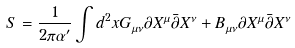Convert formula to latex. <formula><loc_0><loc_0><loc_500><loc_500>S = \frac { 1 } { 2 \pi \alpha ^ { \prime } } \int d ^ { 2 } x G _ { \mu \nu } \partial X ^ { \mu } \bar { \partial } X ^ { \nu } + B _ { \mu \nu } \partial X ^ { \mu } \bar { \partial } X ^ { \nu }</formula> 